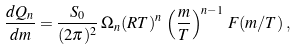<formula> <loc_0><loc_0><loc_500><loc_500>\frac { d Q _ { n } } { d m } = \frac { S _ { 0 } } { ( 2 \pi ) ^ { 2 } } \, \Omega _ { n } ( R T ) ^ { n } \, \left ( \frac { m } { T } \right ) ^ { n - 1 } \, F ( m / T ) \, ,</formula> 